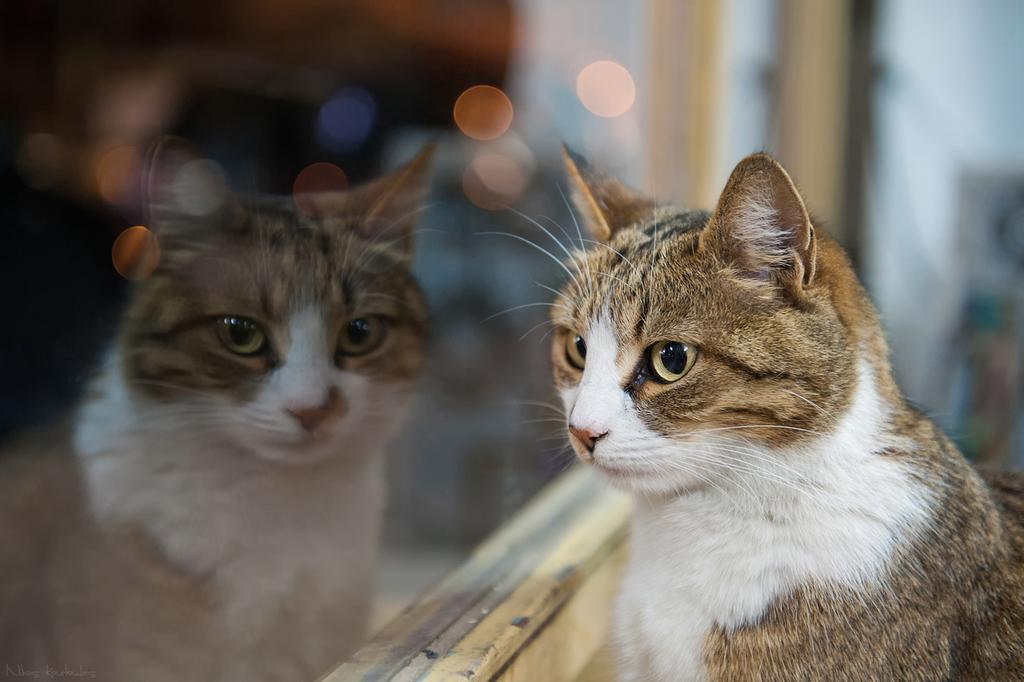How would you summarize this image in a sentence or two? In this image we can see a cat and its reflection. We can also see some lights. 